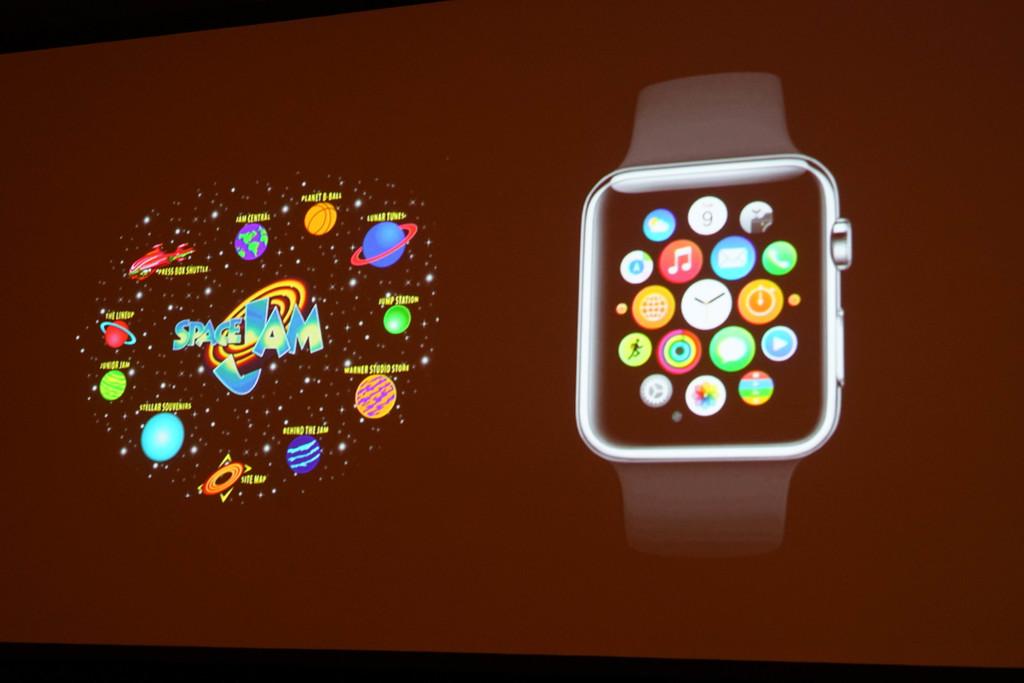What does it say on the left?
Keep it short and to the point. Spacejam. 